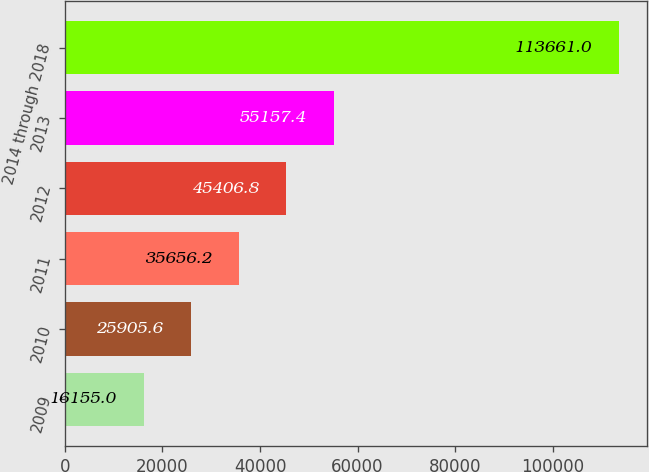<chart> <loc_0><loc_0><loc_500><loc_500><bar_chart><fcel>2009<fcel>2010<fcel>2011<fcel>2012<fcel>2013<fcel>2014 through 2018<nl><fcel>16155<fcel>25905.6<fcel>35656.2<fcel>45406.8<fcel>55157.4<fcel>113661<nl></chart> 